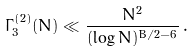<formula> <loc_0><loc_0><loc_500><loc_500>\Gamma _ { 3 } ^ { ( 2 ) } ( N ) \ll \frac { N ^ { 2 } } { ( \log N ) ^ { B / 2 - 6 } } \, .</formula> 